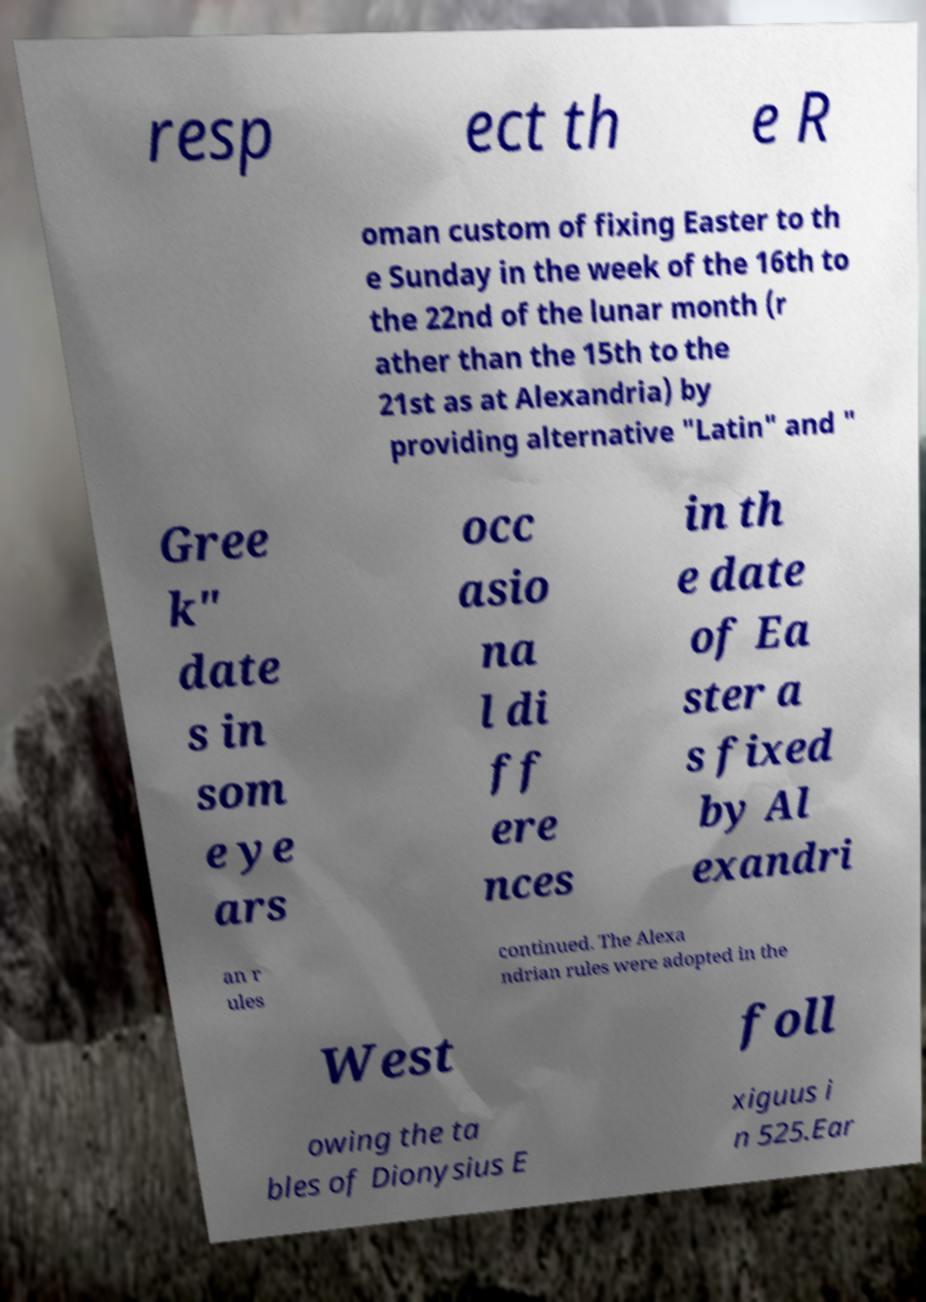I need the written content from this picture converted into text. Can you do that? resp ect th e R oman custom of fixing Easter to th e Sunday in the week of the 16th to the 22nd of the lunar month (r ather than the 15th to the 21st as at Alexandria) by providing alternative "Latin" and " Gree k" date s in som e ye ars occ asio na l di ff ere nces in th e date of Ea ster a s fixed by Al exandri an r ules continued. The Alexa ndrian rules were adopted in the West foll owing the ta bles of Dionysius E xiguus i n 525.Ear 